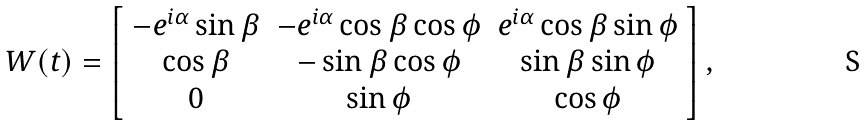<formula> <loc_0><loc_0><loc_500><loc_500>W ( t ) = \left [ \begin{array} { c c c } - e ^ { i \alpha } \sin \beta & - e ^ { i \alpha } \cos \beta \cos \phi & e ^ { i \alpha } \cos \beta \sin \phi \\ \cos \beta & - \sin \beta \cos \phi & \sin \beta \sin \phi \\ 0 & \sin \phi & \cos \phi \\ \end{array} \right ] ,</formula> 